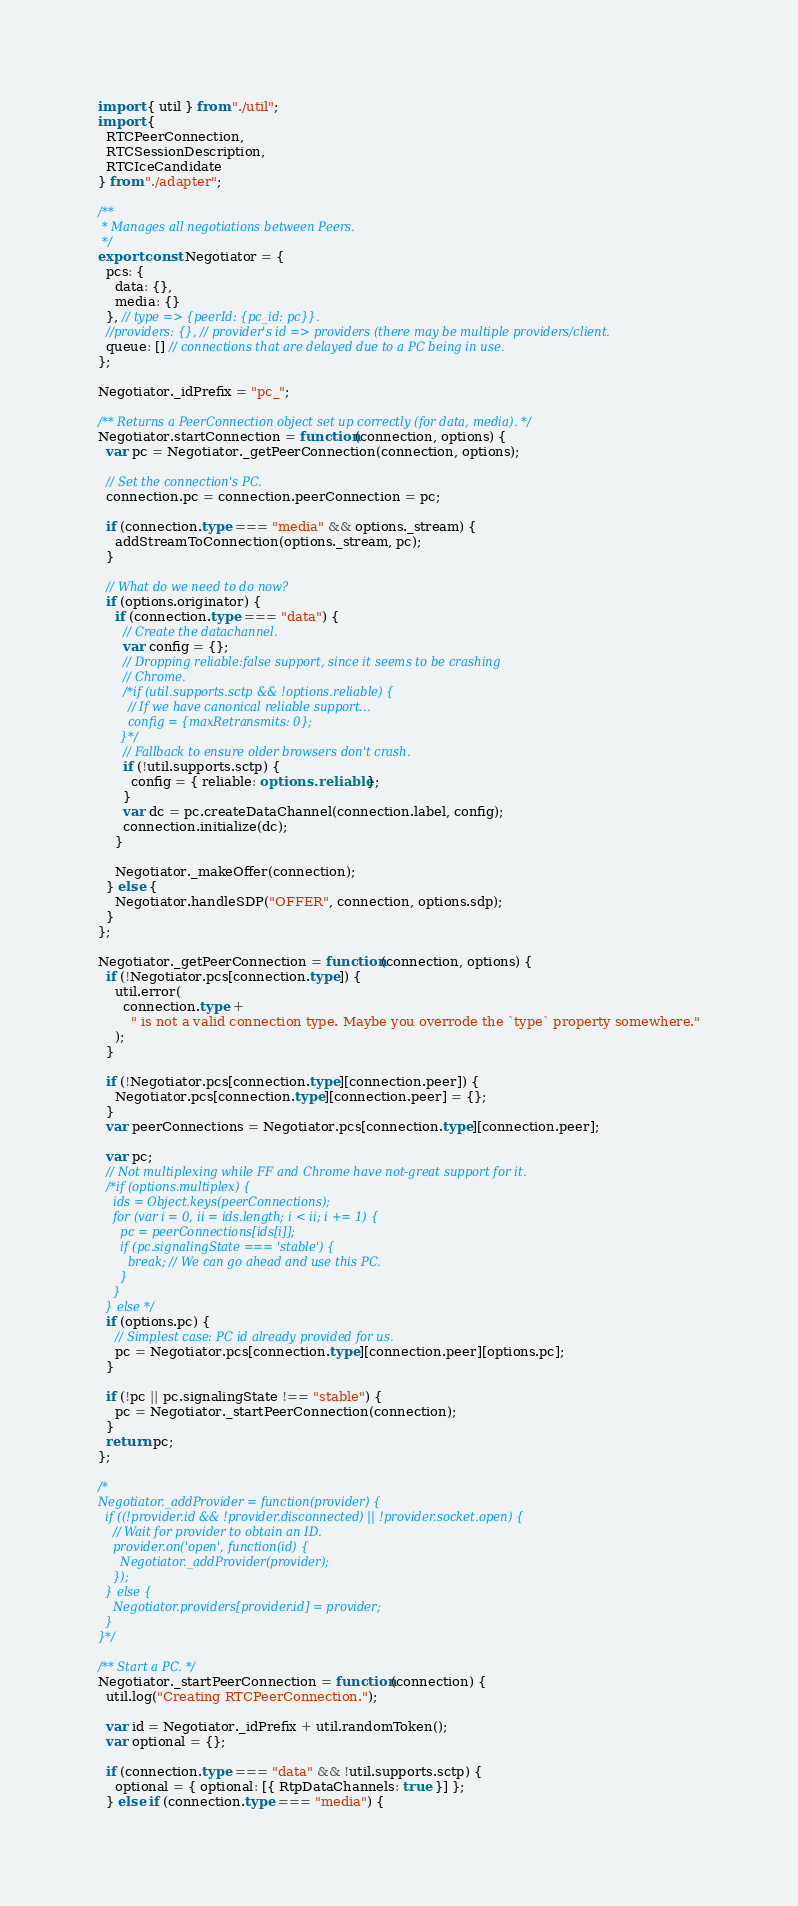<code> <loc_0><loc_0><loc_500><loc_500><_TypeScript_>import { util } from "./util";
import {
  RTCPeerConnection,
  RTCSessionDescription,
  RTCIceCandidate
} from "./adapter";

/**
 * Manages all negotiations between Peers.
 */
export const Negotiator = {
  pcs: {
    data: {},
    media: {}
  }, // type => {peerId: {pc_id: pc}}.
  //providers: {}, // provider's id => providers (there may be multiple providers/client.
  queue: [] // connections that are delayed due to a PC being in use.
};

Negotiator._idPrefix = "pc_";

/** Returns a PeerConnection object set up correctly (for data, media). */
Negotiator.startConnection = function(connection, options) {
  var pc = Negotiator._getPeerConnection(connection, options);

  // Set the connection's PC.
  connection.pc = connection.peerConnection = pc;

  if (connection.type === "media" && options._stream) {
    addStreamToConnection(options._stream, pc);
  }

  // What do we need to do now?
  if (options.originator) {
    if (connection.type === "data") {
      // Create the datachannel.
      var config = {};
      // Dropping reliable:false support, since it seems to be crashing
      // Chrome.
      /*if (util.supports.sctp && !options.reliable) {
        // If we have canonical reliable support...
        config = {maxRetransmits: 0};
      }*/
      // Fallback to ensure older browsers don't crash.
      if (!util.supports.sctp) {
        config = { reliable: options.reliable };
      }
      var dc = pc.createDataChannel(connection.label, config);
      connection.initialize(dc);
    }

    Negotiator._makeOffer(connection);
  } else {
    Negotiator.handleSDP("OFFER", connection, options.sdp);
  }
};

Negotiator._getPeerConnection = function(connection, options) {
  if (!Negotiator.pcs[connection.type]) {
    util.error(
      connection.type +
        " is not a valid connection type. Maybe you overrode the `type` property somewhere."
    );
  }

  if (!Negotiator.pcs[connection.type][connection.peer]) {
    Negotiator.pcs[connection.type][connection.peer] = {};
  }
  var peerConnections = Negotiator.pcs[connection.type][connection.peer];

  var pc;
  // Not multiplexing while FF and Chrome have not-great support for it.
  /*if (options.multiplex) {
    ids = Object.keys(peerConnections);
    for (var i = 0, ii = ids.length; i < ii; i += 1) {
      pc = peerConnections[ids[i]];
      if (pc.signalingState === 'stable') {
        break; // We can go ahead and use this PC.
      }
    }
  } else */
  if (options.pc) {
    // Simplest case: PC id already provided for us.
    pc = Negotiator.pcs[connection.type][connection.peer][options.pc];
  }

  if (!pc || pc.signalingState !== "stable") {
    pc = Negotiator._startPeerConnection(connection);
  }
  return pc;
};

/*
Negotiator._addProvider = function(provider) {
  if ((!provider.id && !provider.disconnected) || !provider.socket.open) {
    // Wait for provider to obtain an ID.
    provider.on('open', function(id) {
      Negotiator._addProvider(provider);
    });
  } else {
    Negotiator.providers[provider.id] = provider;
  }
}*/

/** Start a PC. */
Negotiator._startPeerConnection = function(connection) {
  util.log("Creating RTCPeerConnection.");

  var id = Negotiator._idPrefix + util.randomToken();
  var optional = {};

  if (connection.type === "data" && !util.supports.sctp) {
    optional = { optional: [{ RtpDataChannels: true }] };
  } else if (connection.type === "media") {</code> 